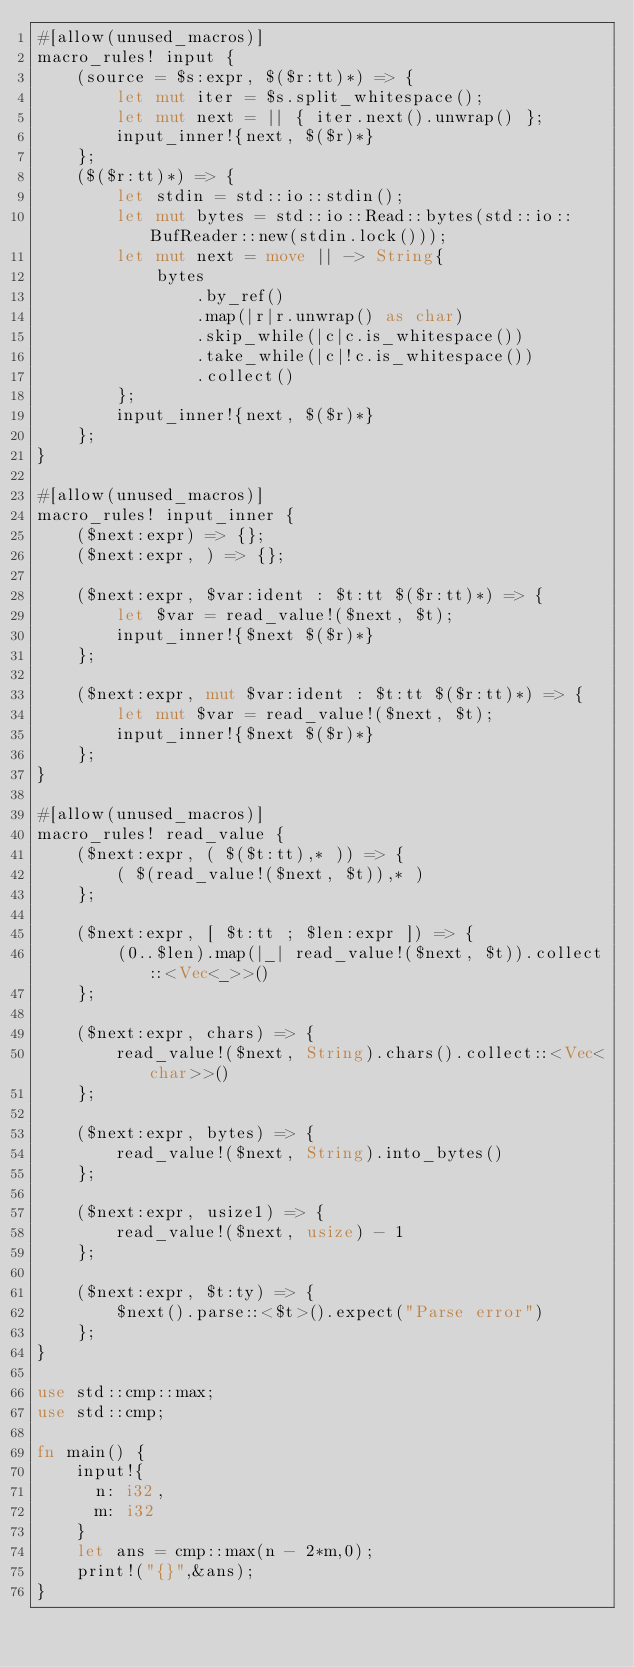Convert code to text. <code><loc_0><loc_0><loc_500><loc_500><_Rust_>#[allow(unused_macros)]
macro_rules! input {
    (source = $s:expr, $($r:tt)*) => {
        let mut iter = $s.split_whitespace();
        let mut next = || { iter.next().unwrap() };
        input_inner!{next, $($r)*}
    };
    ($($r:tt)*) => {
        let stdin = std::io::stdin();
        let mut bytes = std::io::Read::bytes(std::io::BufReader::new(stdin.lock()));
        let mut next = move || -> String{
            bytes
                .by_ref()
                .map(|r|r.unwrap() as char)
                .skip_while(|c|c.is_whitespace())
                .take_while(|c|!c.is_whitespace())
                .collect()
        };
        input_inner!{next, $($r)*}
    };
}
 
#[allow(unused_macros)]
macro_rules! input_inner {
    ($next:expr) => {};
    ($next:expr, ) => {};
 
    ($next:expr, $var:ident : $t:tt $($r:tt)*) => {
        let $var = read_value!($next, $t);
        input_inner!{$next $($r)*}
    };
 
    ($next:expr, mut $var:ident : $t:tt $($r:tt)*) => {
        let mut $var = read_value!($next, $t);
        input_inner!{$next $($r)*}
    };
}
 
#[allow(unused_macros)]
macro_rules! read_value {
    ($next:expr, ( $($t:tt),* )) => {
        ( $(read_value!($next, $t)),* )
    };
 
    ($next:expr, [ $t:tt ; $len:expr ]) => {
        (0..$len).map(|_| read_value!($next, $t)).collect::<Vec<_>>()
    };
 
    ($next:expr, chars) => {
        read_value!($next, String).chars().collect::<Vec<char>>()
    };
 
    ($next:expr, bytes) => {
        read_value!($next, String).into_bytes()
    };
 
    ($next:expr, usize1) => {
        read_value!($next, usize) - 1
    };
 
    ($next:expr, $t:ty) => {
        $next().parse::<$t>().expect("Parse error")
    };
}
 
use std::cmp::max;
use std::cmp;

fn main() {
    input!{
    	n: i32,
    	m: i32
    }
    let ans = cmp::max(n - 2*m,0);
    print!("{}",&ans);
}
</code> 